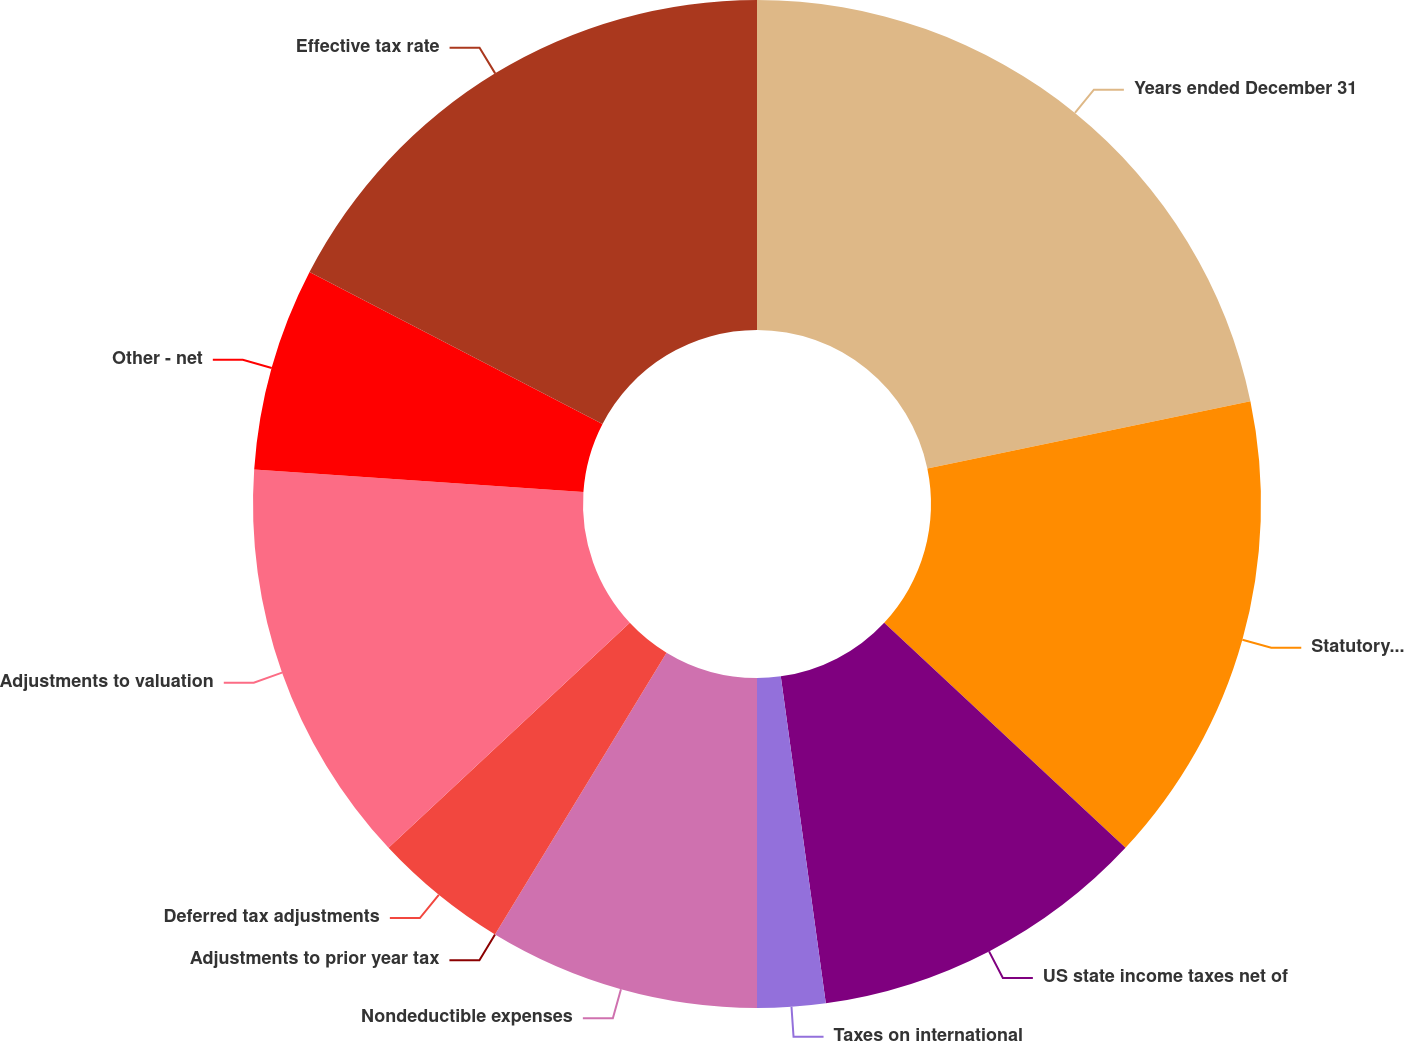<chart> <loc_0><loc_0><loc_500><loc_500><pie_chart><fcel>Years ended December 31<fcel>Statutory tax rate<fcel>US state income taxes net of<fcel>Taxes on international<fcel>Nondeductible expenses<fcel>Adjustments to prior year tax<fcel>Deferred tax adjustments<fcel>Adjustments to valuation<fcel>Other - net<fcel>Effective tax rate<nl><fcel>21.73%<fcel>15.22%<fcel>10.87%<fcel>2.18%<fcel>8.7%<fcel>0.0%<fcel>4.35%<fcel>13.04%<fcel>6.52%<fcel>17.39%<nl></chart> 